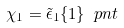<formula> <loc_0><loc_0><loc_500><loc_500>\chi _ { 1 } = \tilde { \epsilon } _ { 1 } \{ 1 \} \ p n t</formula> 